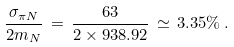<formula> <loc_0><loc_0><loc_500><loc_500>\frac { \sigma _ { \pi N } } { 2 m _ { N } } \, = \, \frac { 6 3 } { 2 \times 9 3 8 . 9 2 } \, \simeq \, 3 . 3 5 \% \, .</formula> 